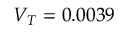<formula> <loc_0><loc_0><loc_500><loc_500>V _ { T } = 0 . 0 0 3 9</formula> 